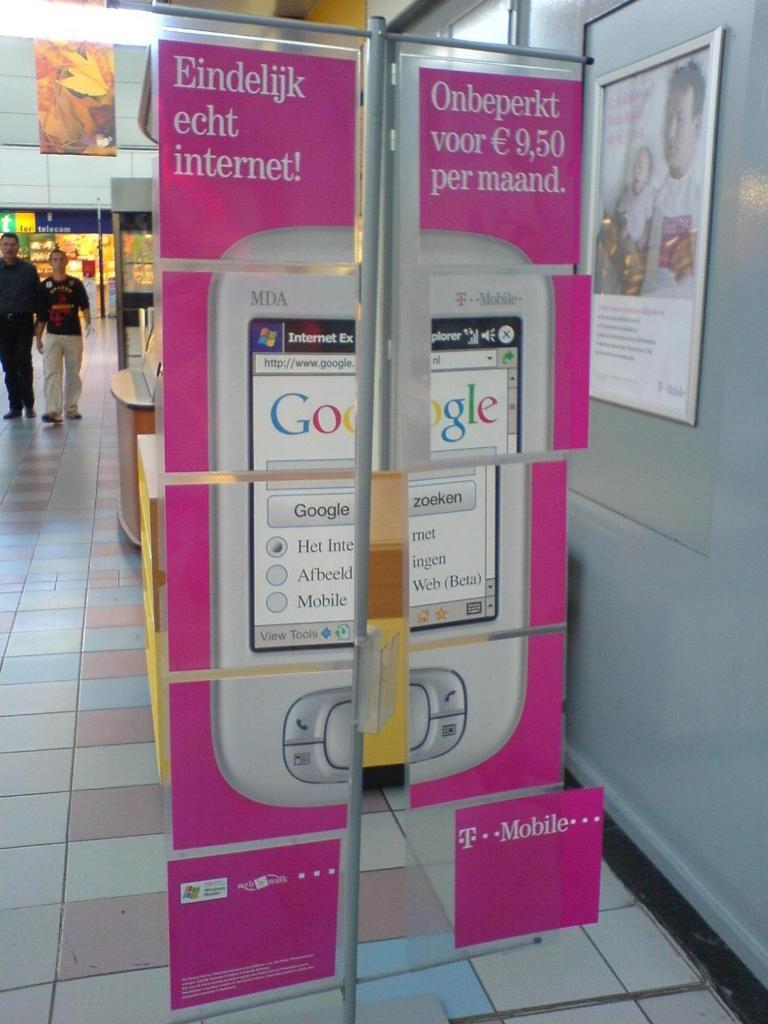<image>
Give a short and clear explanation of the subsequent image. Cardboard display of a cell phone with Google on it in a shopping center 